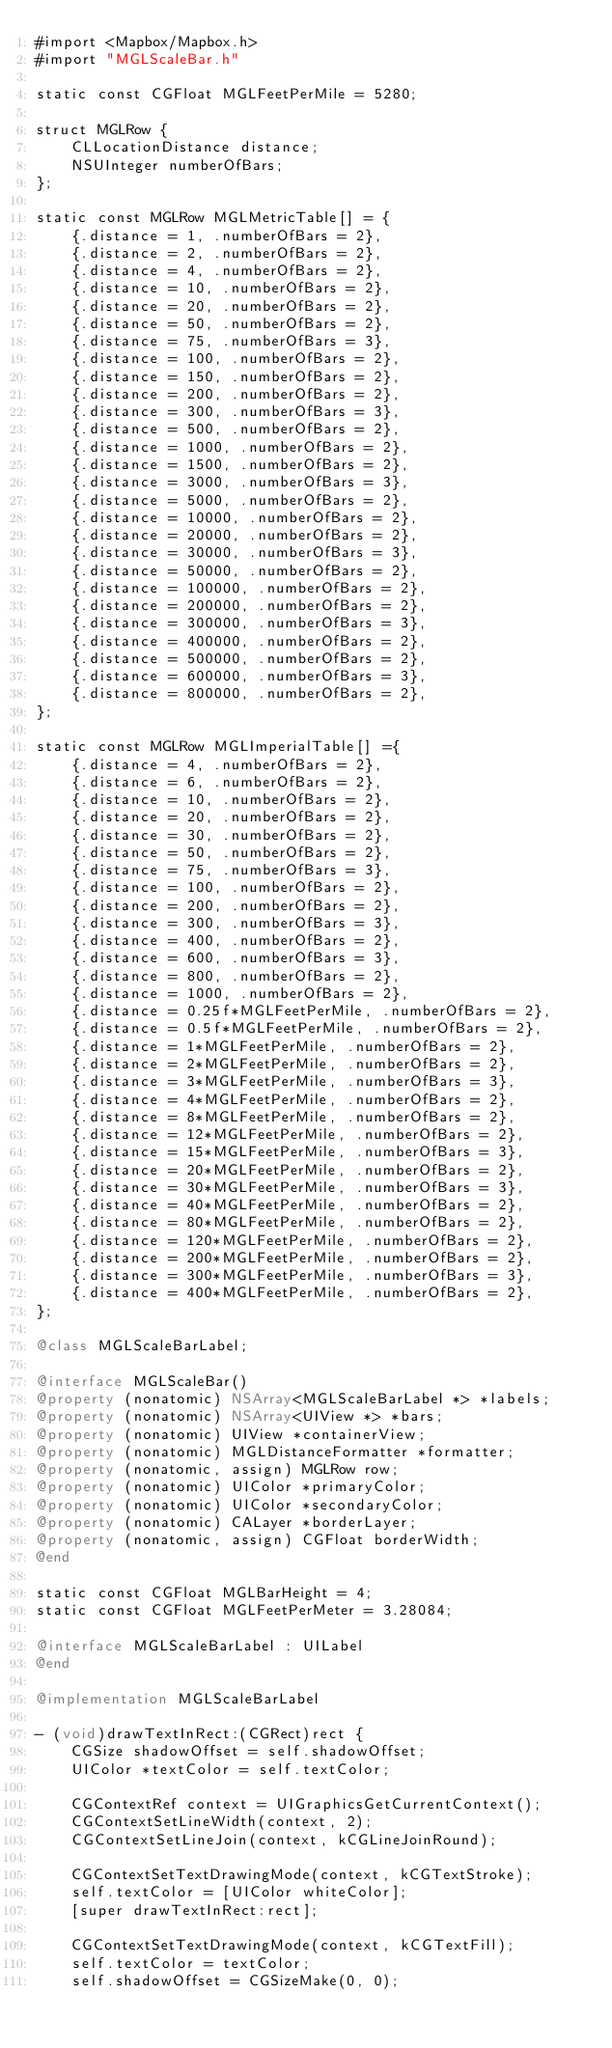<code> <loc_0><loc_0><loc_500><loc_500><_ObjectiveC_>#import <Mapbox/Mapbox.h>
#import "MGLScaleBar.h"

static const CGFloat MGLFeetPerMile = 5280;

struct MGLRow {
    CLLocationDistance distance;
    NSUInteger numberOfBars;
};

static const MGLRow MGLMetricTable[] = {
    {.distance = 1, .numberOfBars = 2},
    {.distance = 2, .numberOfBars = 2},
    {.distance = 4, .numberOfBars = 2},
    {.distance = 10, .numberOfBars = 2},
    {.distance = 20, .numberOfBars = 2},
    {.distance = 50, .numberOfBars = 2},
    {.distance = 75, .numberOfBars = 3},
    {.distance = 100, .numberOfBars = 2},
    {.distance = 150, .numberOfBars = 2},
    {.distance = 200, .numberOfBars = 2},
    {.distance = 300, .numberOfBars = 3},
    {.distance = 500, .numberOfBars = 2},
    {.distance = 1000, .numberOfBars = 2},
    {.distance = 1500, .numberOfBars = 2},
    {.distance = 3000, .numberOfBars = 3},
    {.distance = 5000, .numberOfBars = 2},
    {.distance = 10000, .numberOfBars = 2},
    {.distance = 20000, .numberOfBars = 2},
    {.distance = 30000, .numberOfBars = 3},
    {.distance = 50000, .numberOfBars = 2},
    {.distance = 100000, .numberOfBars = 2},
    {.distance = 200000, .numberOfBars = 2},
    {.distance = 300000, .numberOfBars = 3},
    {.distance = 400000, .numberOfBars = 2},
    {.distance = 500000, .numberOfBars = 2},
    {.distance = 600000, .numberOfBars = 3},
    {.distance = 800000, .numberOfBars = 2},
};

static const MGLRow MGLImperialTable[] ={
    {.distance = 4, .numberOfBars = 2},
    {.distance = 6, .numberOfBars = 2},
    {.distance = 10, .numberOfBars = 2},
    {.distance = 20, .numberOfBars = 2},
    {.distance = 30, .numberOfBars = 2},
    {.distance = 50, .numberOfBars = 2},
    {.distance = 75, .numberOfBars = 3},
    {.distance = 100, .numberOfBars = 2},
    {.distance = 200, .numberOfBars = 2},
    {.distance = 300, .numberOfBars = 3},
    {.distance = 400, .numberOfBars = 2},
    {.distance = 600, .numberOfBars = 3},
    {.distance = 800, .numberOfBars = 2},
    {.distance = 1000, .numberOfBars = 2},
    {.distance = 0.25f*MGLFeetPerMile, .numberOfBars = 2},
    {.distance = 0.5f*MGLFeetPerMile, .numberOfBars = 2},
    {.distance = 1*MGLFeetPerMile, .numberOfBars = 2},
    {.distance = 2*MGLFeetPerMile, .numberOfBars = 2},
    {.distance = 3*MGLFeetPerMile, .numberOfBars = 3},
    {.distance = 4*MGLFeetPerMile, .numberOfBars = 2},
    {.distance = 8*MGLFeetPerMile, .numberOfBars = 2},
    {.distance = 12*MGLFeetPerMile, .numberOfBars = 2},
    {.distance = 15*MGLFeetPerMile, .numberOfBars = 3},
    {.distance = 20*MGLFeetPerMile, .numberOfBars = 2},
    {.distance = 30*MGLFeetPerMile, .numberOfBars = 3},
    {.distance = 40*MGLFeetPerMile, .numberOfBars = 2},
    {.distance = 80*MGLFeetPerMile, .numberOfBars = 2},
    {.distance = 120*MGLFeetPerMile, .numberOfBars = 2},
    {.distance = 200*MGLFeetPerMile, .numberOfBars = 2},
    {.distance = 300*MGLFeetPerMile, .numberOfBars = 3},
    {.distance = 400*MGLFeetPerMile, .numberOfBars = 2},
};

@class MGLScaleBarLabel;

@interface MGLScaleBar()
@property (nonatomic) NSArray<MGLScaleBarLabel *> *labels;
@property (nonatomic) NSArray<UIView *> *bars;
@property (nonatomic) UIView *containerView;
@property (nonatomic) MGLDistanceFormatter *formatter;
@property (nonatomic, assign) MGLRow row;
@property (nonatomic) UIColor *primaryColor;
@property (nonatomic) UIColor *secondaryColor;
@property (nonatomic) CALayer *borderLayer;
@property (nonatomic, assign) CGFloat borderWidth;
@end

static const CGFloat MGLBarHeight = 4;
static const CGFloat MGLFeetPerMeter = 3.28084;

@interface MGLScaleBarLabel : UILabel
@end

@implementation MGLScaleBarLabel

- (void)drawTextInRect:(CGRect)rect {
    CGSize shadowOffset = self.shadowOffset;
    UIColor *textColor = self.textColor;
    
    CGContextRef context = UIGraphicsGetCurrentContext();
    CGContextSetLineWidth(context, 2);
    CGContextSetLineJoin(context, kCGLineJoinRound);
    
    CGContextSetTextDrawingMode(context, kCGTextStroke);
    self.textColor = [UIColor whiteColor];
    [super drawTextInRect:rect];
    
    CGContextSetTextDrawingMode(context, kCGTextFill);
    self.textColor = textColor;
    self.shadowOffset = CGSizeMake(0, 0);</code> 